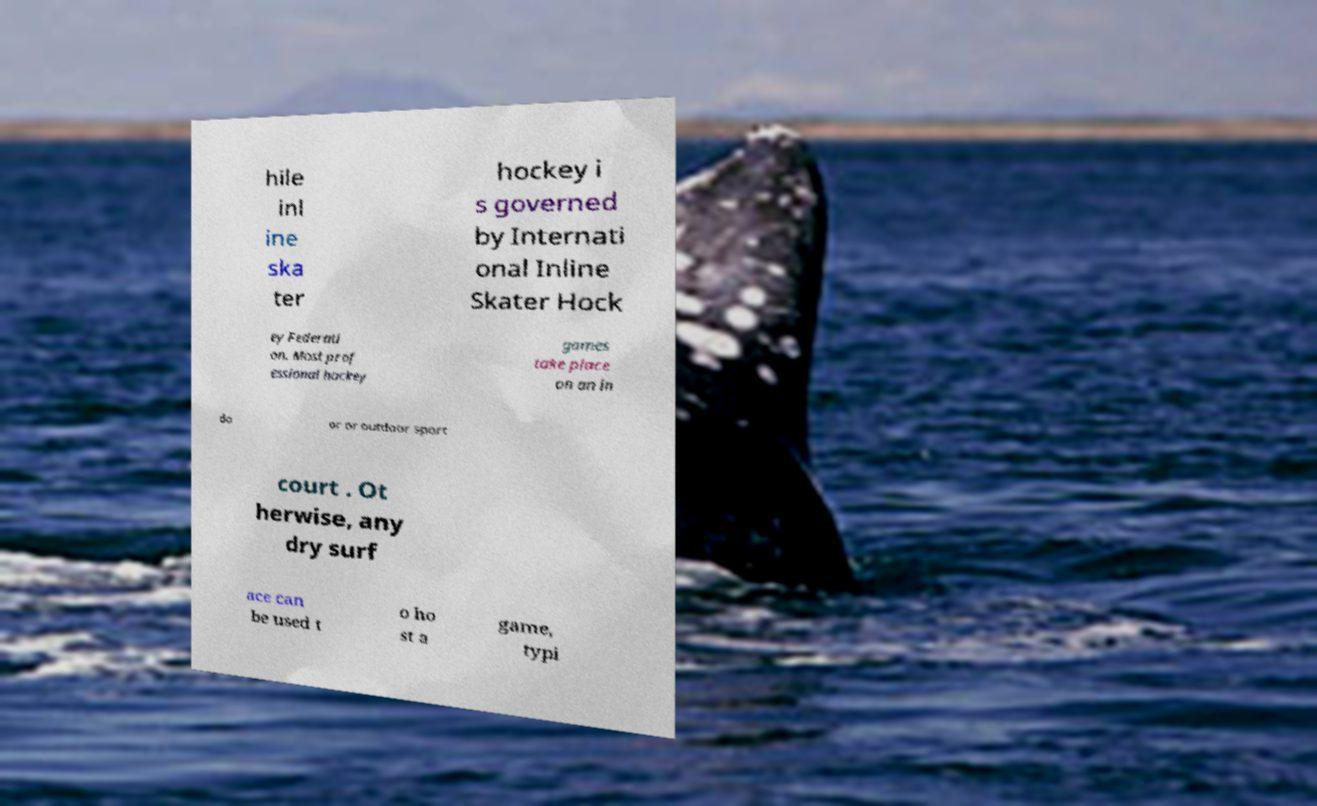Can you read and provide the text displayed in the image?This photo seems to have some interesting text. Can you extract and type it out for me? hile inl ine ska ter hockey i s governed by Internati onal Inline Skater Hock ey Federati on. Most prof essional hockey games take place on an in do or or outdoor sport court . Ot herwise, any dry surf ace can be used t o ho st a game, typi 